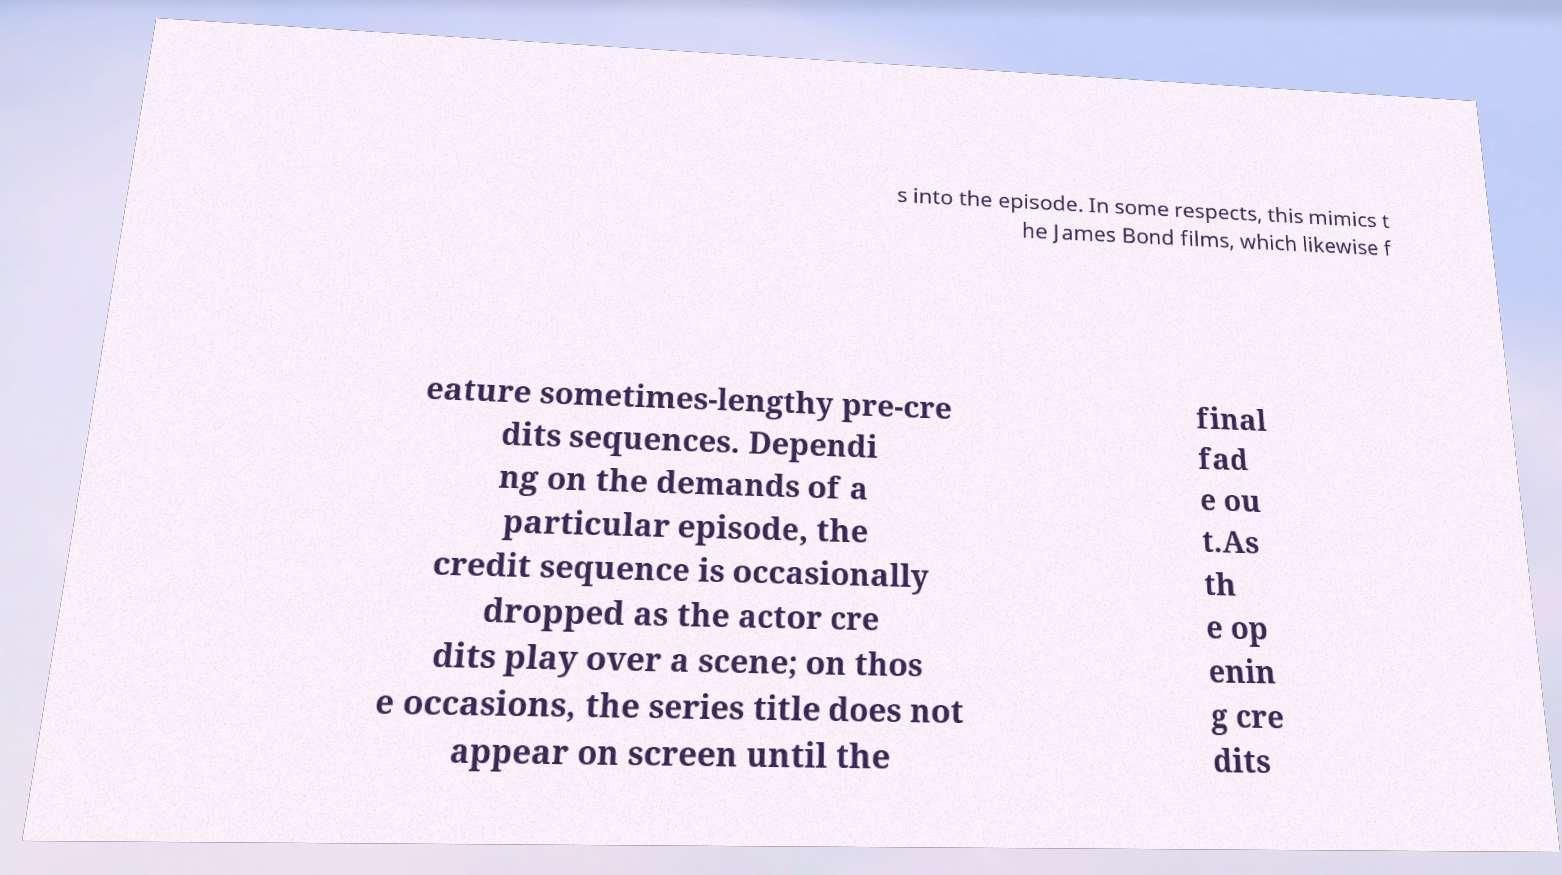Please identify and transcribe the text found in this image. s into the episode. In some respects, this mimics t he James Bond films, which likewise f eature sometimes-lengthy pre-cre dits sequences. Dependi ng on the demands of a particular episode, the credit sequence is occasionally dropped as the actor cre dits play over a scene; on thos e occasions, the series title does not appear on screen until the final fad e ou t.As th e op enin g cre dits 